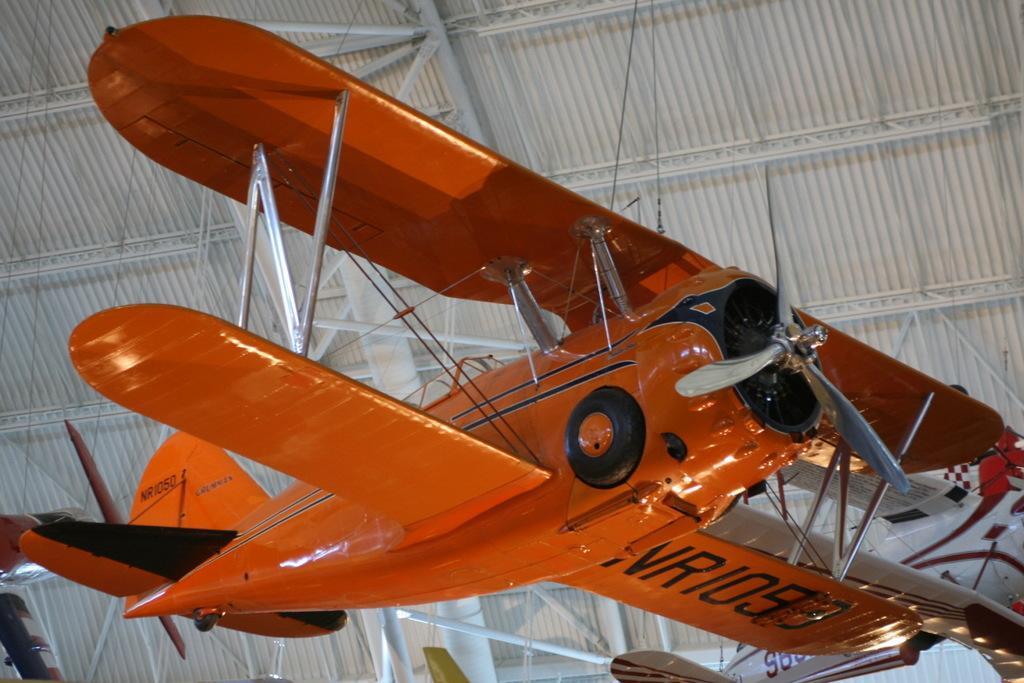Please provide a concise description of this image. In the center of the image, we can see an airplane and at the top, there is roof and we can see rods. 